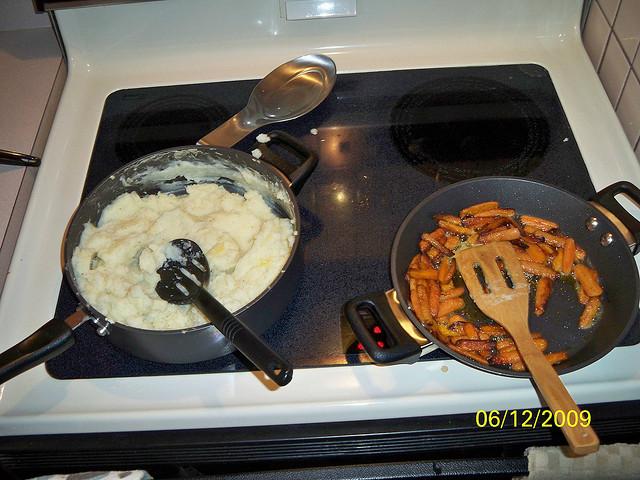What is the person cooking?
Be succinct. Mashed potatoes and carrots. Is this cook stove gas or electric?
Give a very brief answer. Electric. When was the picture taken?
Keep it brief. 6/12/2009. 